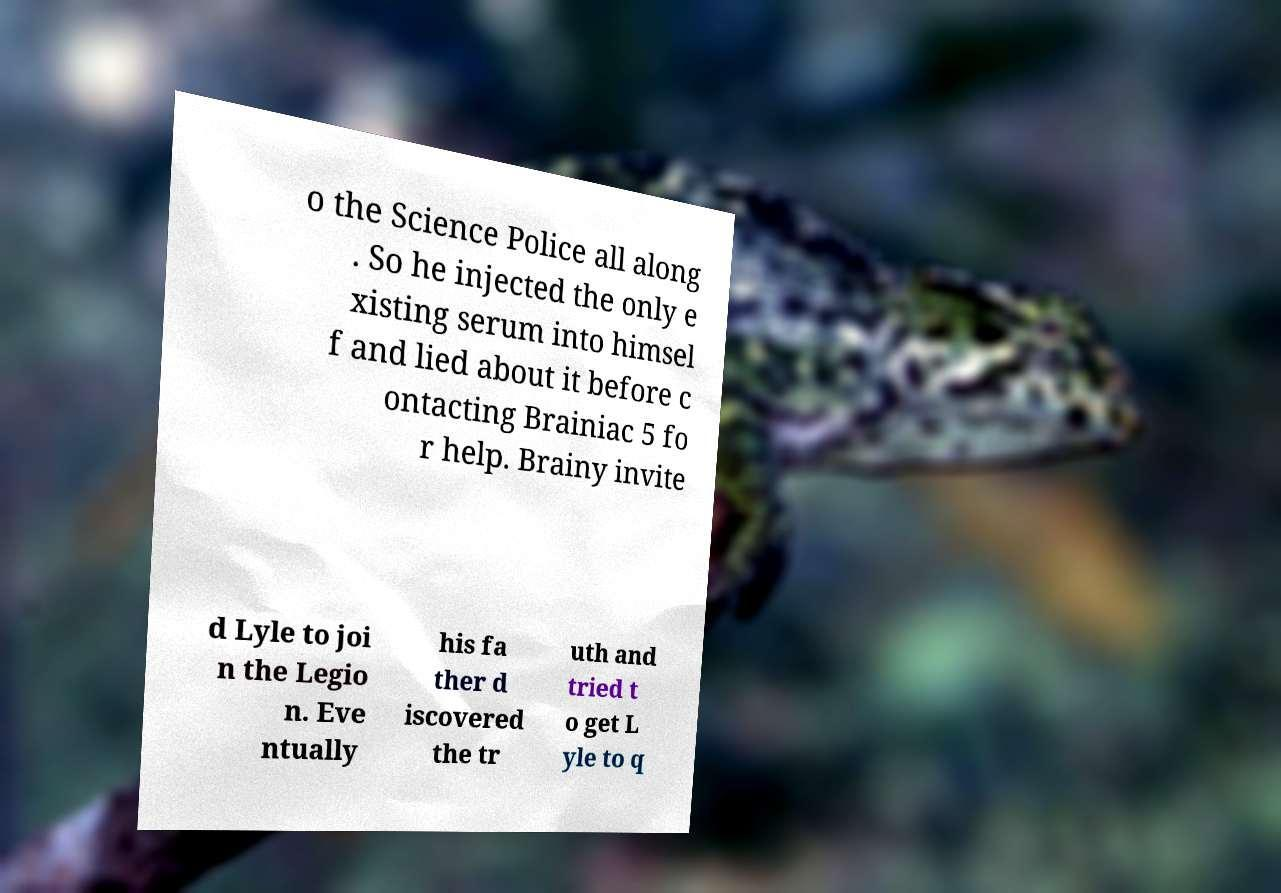Please identify and transcribe the text found in this image. o the Science Police all along . So he injected the only e xisting serum into himsel f and lied about it before c ontacting Brainiac 5 fo r help. Brainy invite d Lyle to joi n the Legio n. Eve ntually his fa ther d iscovered the tr uth and tried t o get L yle to q 